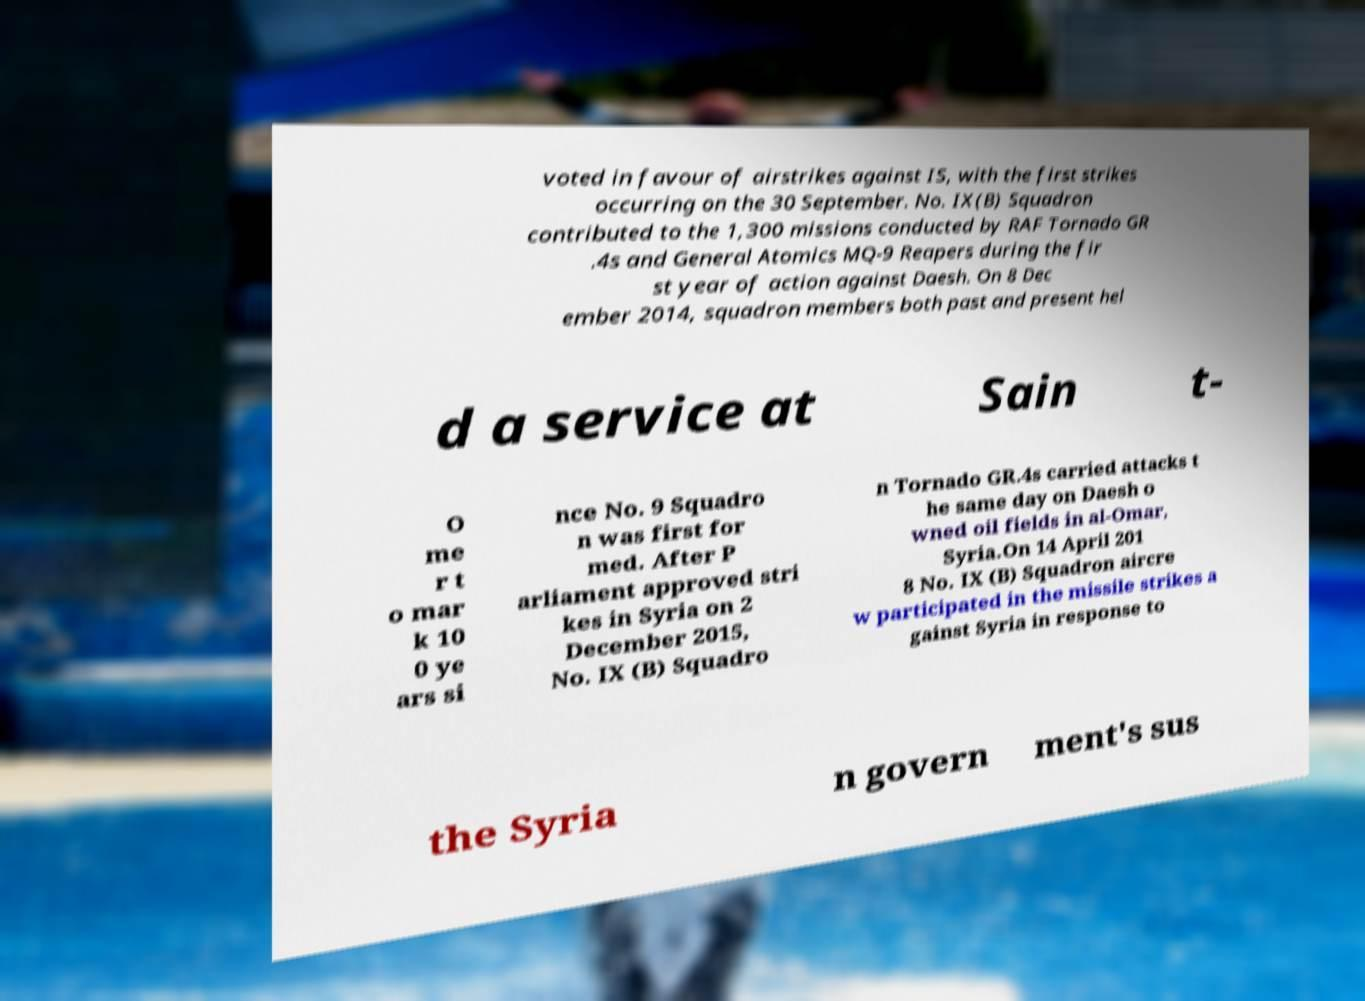Please identify and transcribe the text found in this image. voted in favour of airstrikes against IS, with the first strikes occurring on the 30 September. No. IX(B) Squadron contributed to the 1,300 missions conducted by RAF Tornado GR .4s and General Atomics MQ-9 Reapers during the fir st year of action against Daesh. On 8 Dec ember 2014, squadron members both past and present hel d a service at Sain t- O me r t o mar k 10 0 ye ars si nce No. 9 Squadro n was first for med. After P arliament approved stri kes in Syria on 2 December 2015, No. IX (B) Squadro n Tornado GR.4s carried attacks t he same day on Daesh o wned oil fields in al-Omar, Syria.On 14 April 201 8 No. IX (B) Squadron aircre w participated in the missile strikes a gainst Syria in response to the Syria n govern ment's sus 